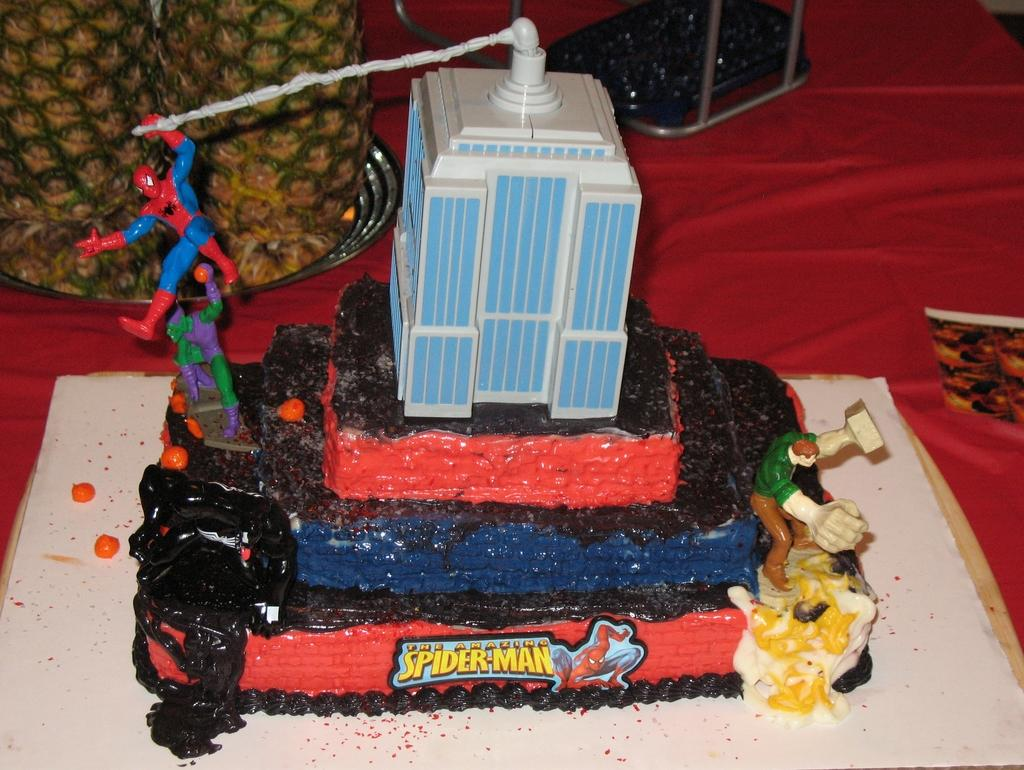What type of objects can be seen in the image? There are toys, a cake, and fruits in the image. What is the color of the surface on which the objects are placed? The objects are placed on a red surface in the image. What type of teaching is happening in the image? There is no teaching activity depicted in the image. Can you see a match in the image? There is no match present in the image. 